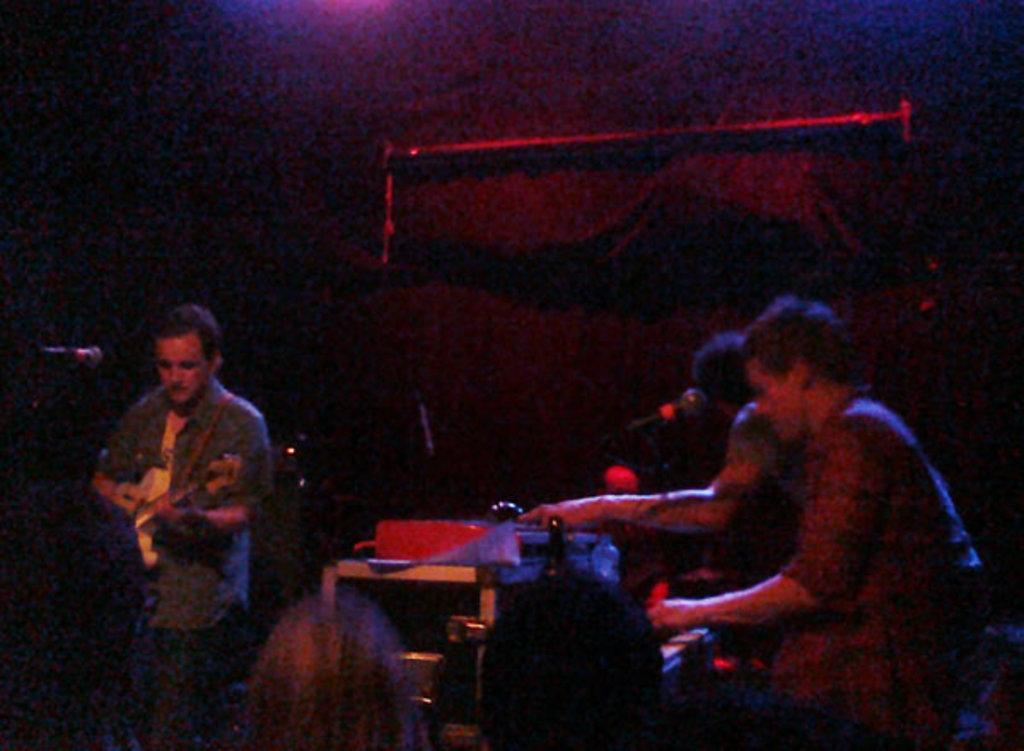What are the people in the image doing? The people in the image are playing musical instruments. What objects are in front of the people? There are microphones in front of the people. How would you describe the lighting in the image? The background of the image is dark. What type of kite can be seen flying in the image? There is no kite present in the image; it features people playing musical instruments with microphones in front of them. 